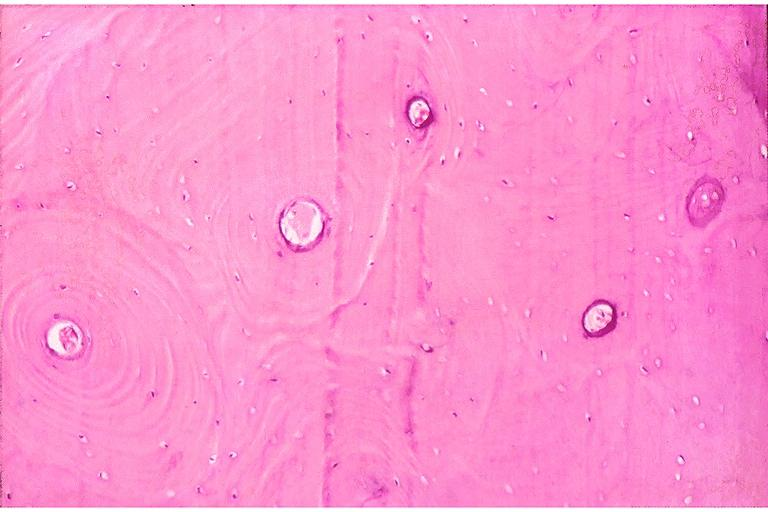does ulcer show dense sclerotic bone?
Answer the question using a single word or phrase. No 